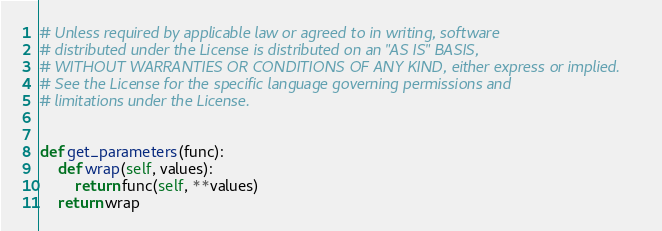<code> <loc_0><loc_0><loc_500><loc_500><_Python_>
# Unless required by applicable law or agreed to in writing, software
# distributed under the License is distributed on an "AS IS" BASIS,
# WITHOUT WARRANTIES OR CONDITIONS OF ANY KIND, either express or implied.
# See the License for the specific language governing permissions and
# limitations under the License.


def get_parameters(func):
    def wrap(self, values):
        return func(self, **values)
    return wrap
</code> 